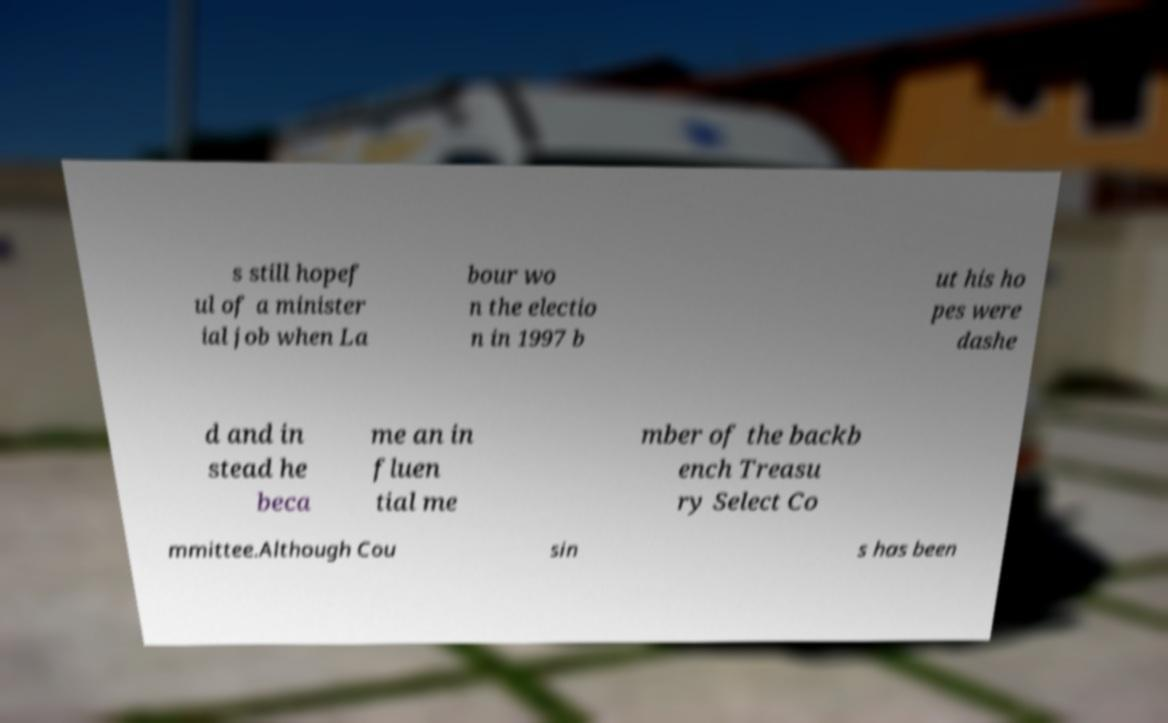There's text embedded in this image that I need extracted. Can you transcribe it verbatim? s still hopef ul of a minister ial job when La bour wo n the electio n in 1997 b ut his ho pes were dashe d and in stead he beca me an in fluen tial me mber of the backb ench Treasu ry Select Co mmittee.Although Cou sin s has been 